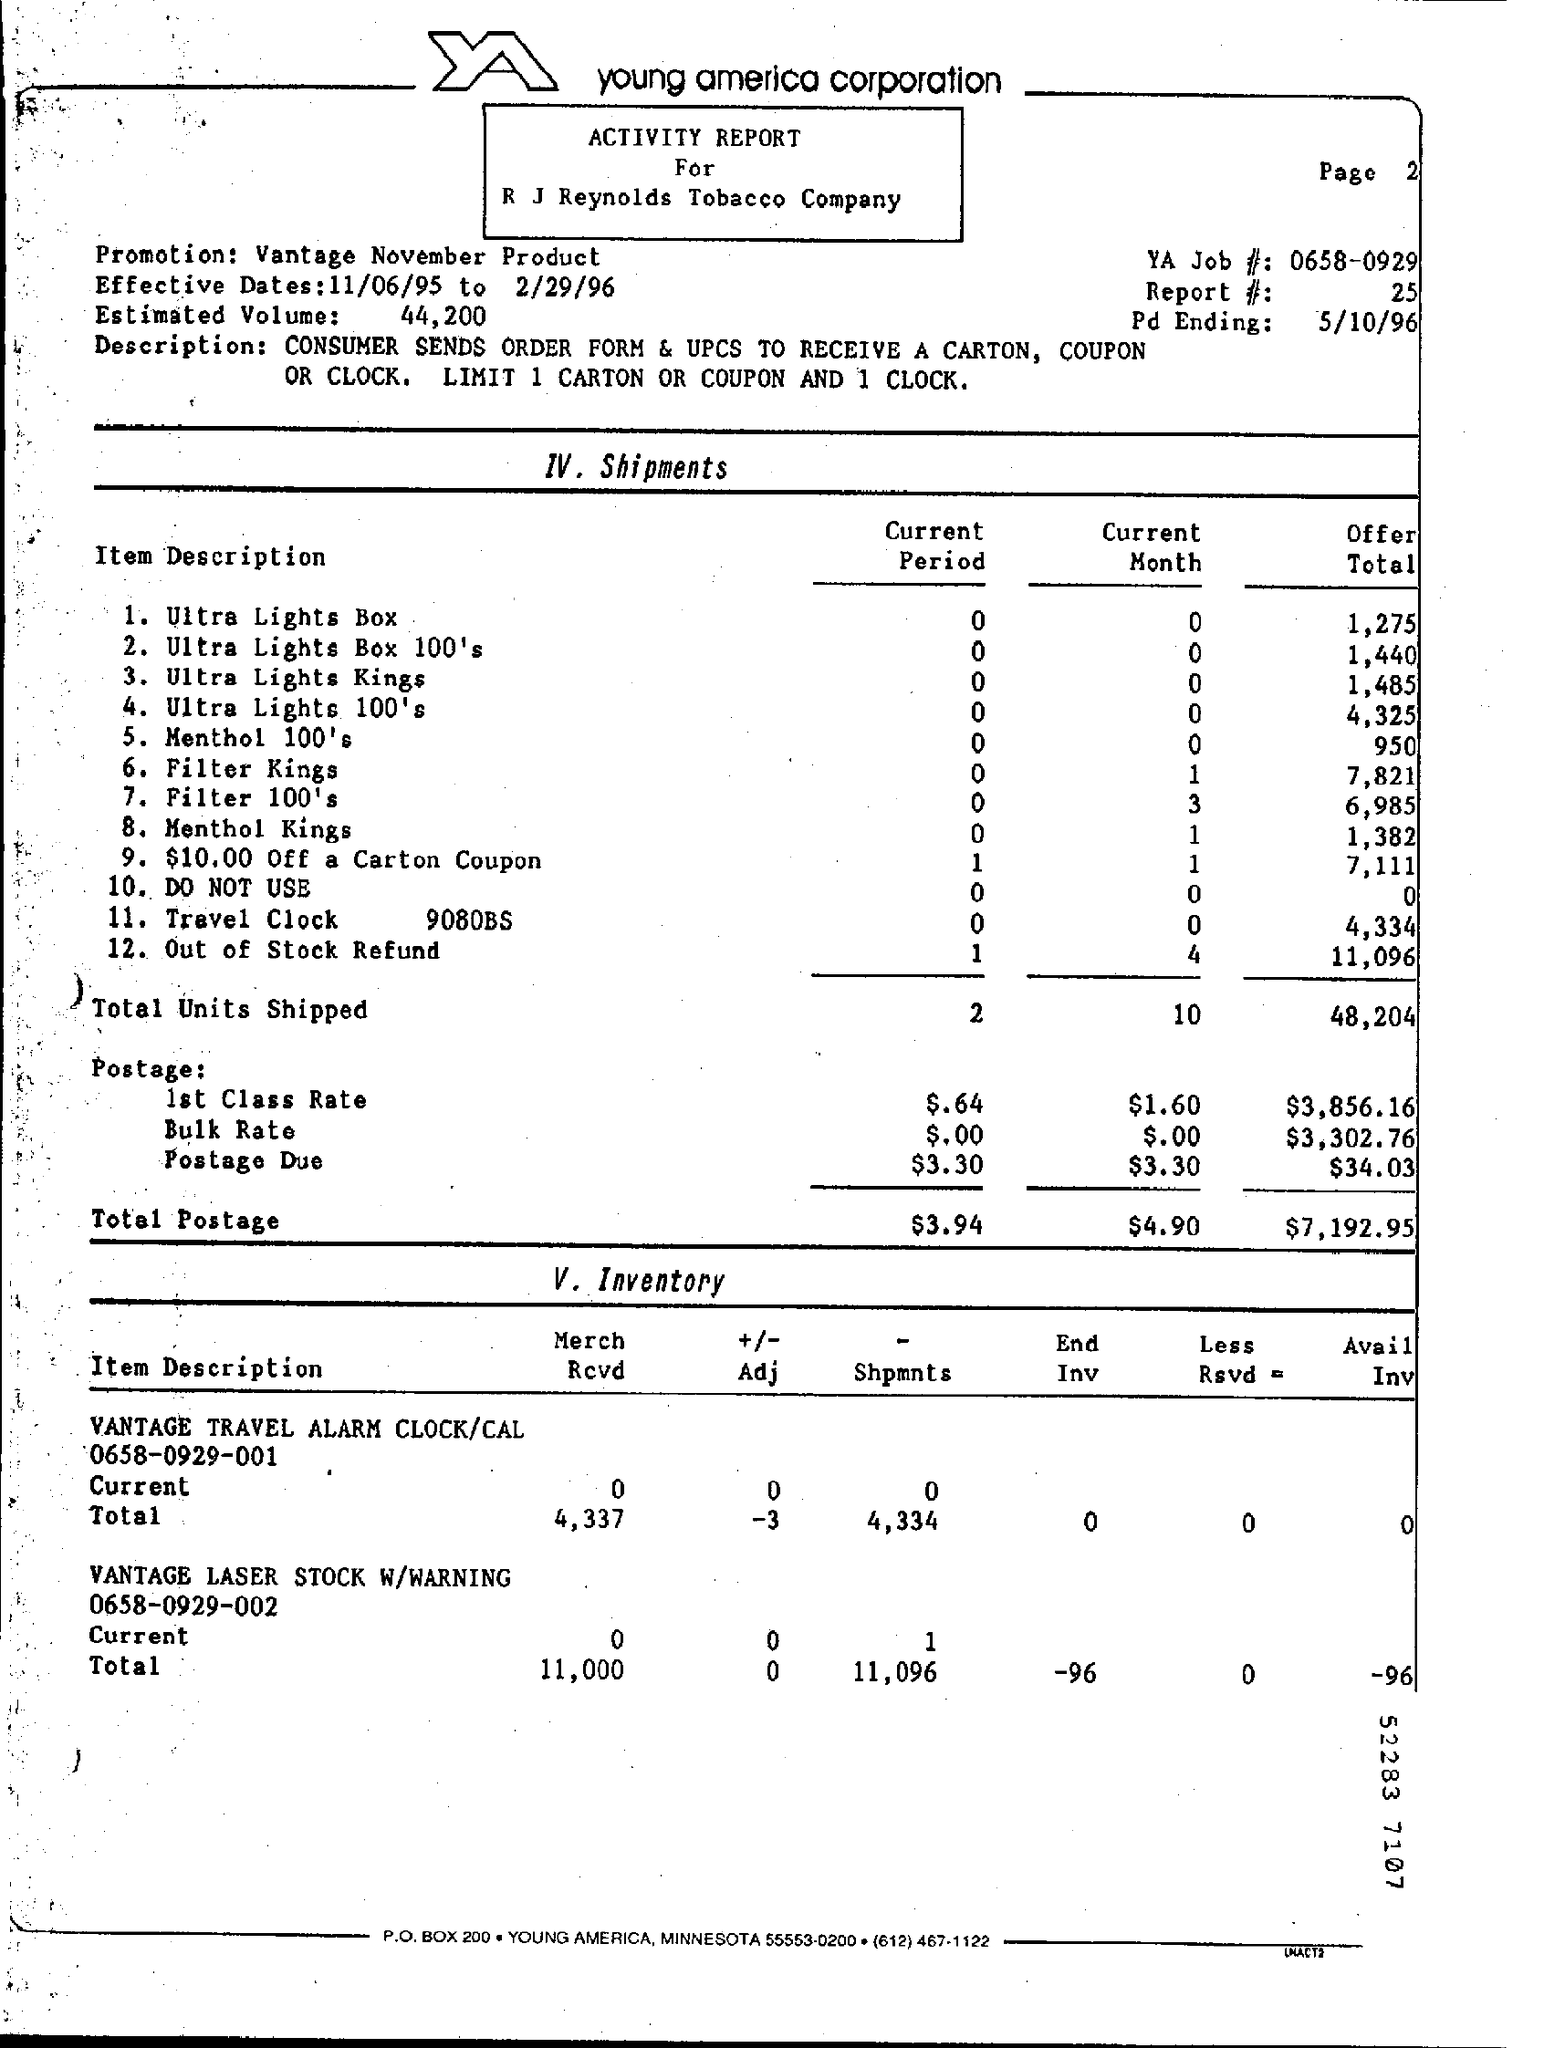Specify some key components in this picture. On May 10th, 1996, the Pd ending was revealed. The Report#/?25..." is a code or command that is used to access a specific report or document. The total number of units shipped for the offer total is 48,204. The effective dates for a specific period of time are from November 6, 1995 to February 29, 1996. The YA Job# is 0658-0929. 